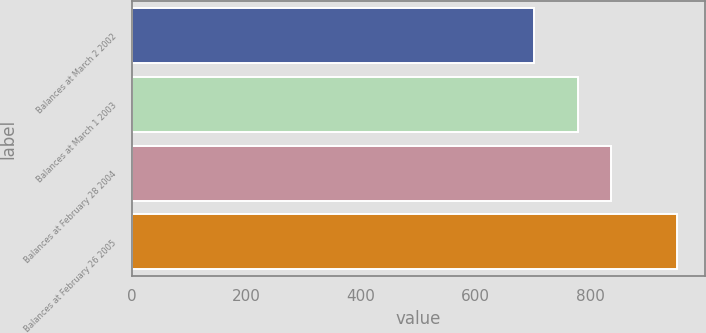<chart> <loc_0><loc_0><loc_500><loc_500><bar_chart><fcel>Balances at March 2 2002<fcel>Balances at March 1 2003<fcel>Balances at February 28 2004<fcel>Balances at February 26 2005<nl><fcel>702<fcel>778<fcel>836<fcel>952<nl></chart> 